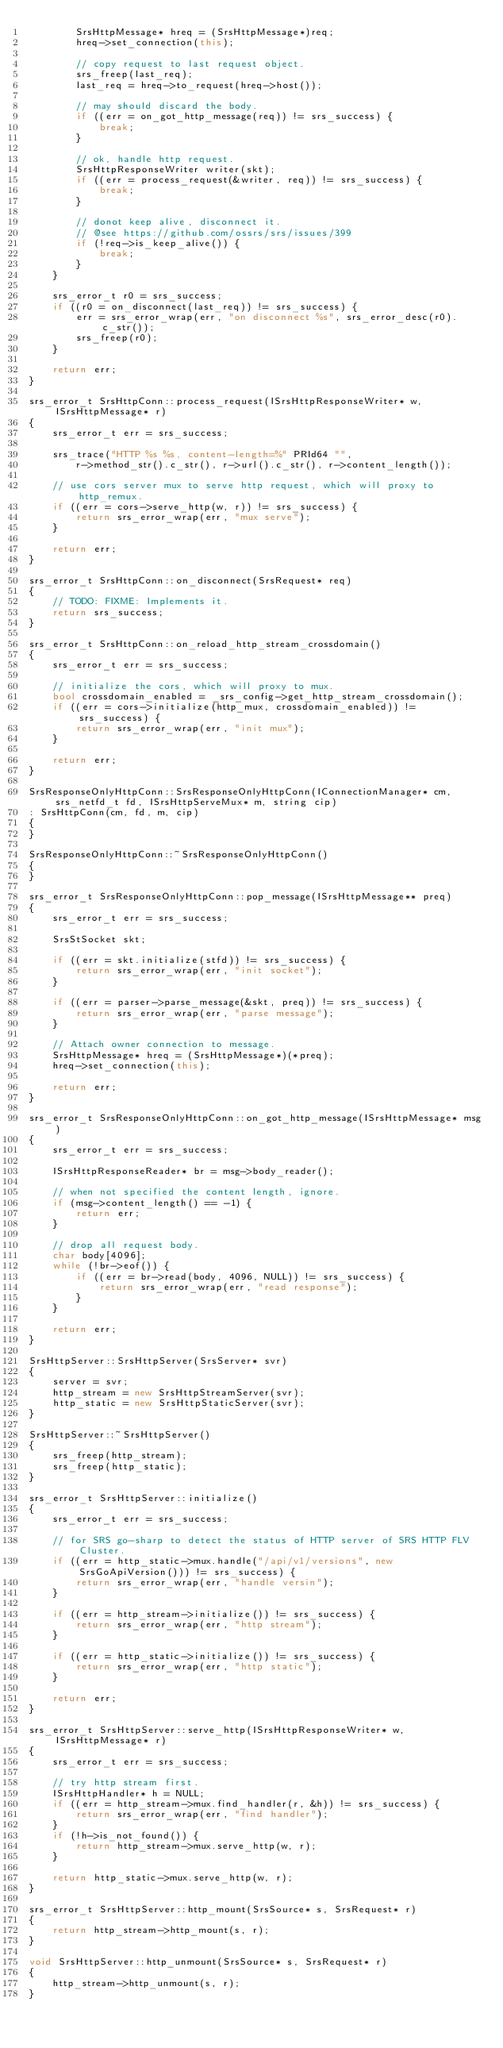<code> <loc_0><loc_0><loc_500><loc_500><_C++_>        SrsHttpMessage* hreq = (SrsHttpMessage*)req;
        hreq->set_connection(this);
        
        // copy request to last request object.
        srs_freep(last_req);
        last_req = hreq->to_request(hreq->host());
        
        // may should discard the body.
        if ((err = on_got_http_message(req)) != srs_success) {
            break;
        }
        
        // ok, handle http request.
        SrsHttpResponseWriter writer(skt);
        if ((err = process_request(&writer, req)) != srs_success) {
            break;
        }
        
        // donot keep alive, disconnect it.
        // @see https://github.com/ossrs/srs/issues/399
        if (!req->is_keep_alive()) {
            break;
        }
    }
    
    srs_error_t r0 = srs_success;
    if ((r0 = on_disconnect(last_req)) != srs_success) {
        err = srs_error_wrap(err, "on disconnect %s", srs_error_desc(r0).c_str());
        srs_freep(r0);
    }
    
    return err;
}

srs_error_t SrsHttpConn::process_request(ISrsHttpResponseWriter* w, ISrsHttpMessage* r)
{
    srs_error_t err = srs_success;
    
    srs_trace("HTTP %s %s, content-length=%" PRId64 "",
        r->method_str().c_str(), r->url().c_str(), r->content_length());
    
    // use cors server mux to serve http request, which will proxy to http_remux.
    if ((err = cors->serve_http(w, r)) != srs_success) {
        return srs_error_wrap(err, "mux serve");
    }
    
    return err;
}

srs_error_t SrsHttpConn::on_disconnect(SrsRequest* req)
{
    // TODO: FIXME: Implements it.
    return srs_success;
}

srs_error_t SrsHttpConn::on_reload_http_stream_crossdomain()
{
    srs_error_t err = srs_success;
    
    // initialize the cors, which will proxy to mux.
    bool crossdomain_enabled = _srs_config->get_http_stream_crossdomain();
    if ((err = cors->initialize(http_mux, crossdomain_enabled)) != srs_success) {
        return srs_error_wrap(err, "init mux");
    }
    
    return err;
}

SrsResponseOnlyHttpConn::SrsResponseOnlyHttpConn(IConnectionManager* cm, srs_netfd_t fd, ISrsHttpServeMux* m, string cip)
: SrsHttpConn(cm, fd, m, cip)
{
}

SrsResponseOnlyHttpConn::~SrsResponseOnlyHttpConn()
{
}

srs_error_t SrsResponseOnlyHttpConn::pop_message(ISrsHttpMessage** preq)
{
    srs_error_t err = srs_success;
    
    SrsStSocket skt;
    
    if ((err = skt.initialize(stfd)) != srs_success) {
        return srs_error_wrap(err, "init socket");
    }
    
    if ((err = parser->parse_message(&skt, preq)) != srs_success) {
        return srs_error_wrap(err, "parse message");
    }
    
    // Attach owner connection to message.
    SrsHttpMessage* hreq = (SrsHttpMessage*)(*preq);
    hreq->set_connection(this);
    
    return err;
}

srs_error_t SrsResponseOnlyHttpConn::on_got_http_message(ISrsHttpMessage* msg)
{
    srs_error_t err = srs_success;
    
    ISrsHttpResponseReader* br = msg->body_reader();
    
    // when not specified the content length, ignore.
    if (msg->content_length() == -1) {
        return err;
    }
    
    // drop all request body.
    char body[4096];
    while (!br->eof()) {
        if ((err = br->read(body, 4096, NULL)) != srs_success) {
            return srs_error_wrap(err, "read response");
        }
    }
    
    return err;
}

SrsHttpServer::SrsHttpServer(SrsServer* svr)
{
    server = svr;
    http_stream = new SrsHttpStreamServer(svr);
    http_static = new SrsHttpStaticServer(svr);
}

SrsHttpServer::~SrsHttpServer()
{
    srs_freep(http_stream);
    srs_freep(http_static);
}

srs_error_t SrsHttpServer::initialize()
{
    srs_error_t err = srs_success;
    
    // for SRS go-sharp to detect the status of HTTP server of SRS HTTP FLV Cluster.
    if ((err = http_static->mux.handle("/api/v1/versions", new SrsGoApiVersion())) != srs_success) {
        return srs_error_wrap(err, "handle versin");
    }
    
    if ((err = http_stream->initialize()) != srs_success) {
        return srs_error_wrap(err, "http stream");
    }
    
    if ((err = http_static->initialize()) != srs_success) {
        return srs_error_wrap(err, "http static");
    }
    
    return err;
}

srs_error_t SrsHttpServer::serve_http(ISrsHttpResponseWriter* w, ISrsHttpMessage* r)
{
    srs_error_t err = srs_success;
    
    // try http stream first.
    ISrsHttpHandler* h = NULL;
    if ((err = http_stream->mux.find_handler(r, &h)) != srs_success) {
        return srs_error_wrap(err, "find handler");
    }
    if (!h->is_not_found()) {
        return http_stream->mux.serve_http(w, r);
    }
    
    return http_static->mux.serve_http(w, r);
}

srs_error_t SrsHttpServer::http_mount(SrsSource* s, SrsRequest* r)
{
    return http_stream->http_mount(s, r);
}

void SrsHttpServer::http_unmount(SrsSource* s, SrsRequest* r)
{
    http_stream->http_unmount(s, r);
}

</code> 